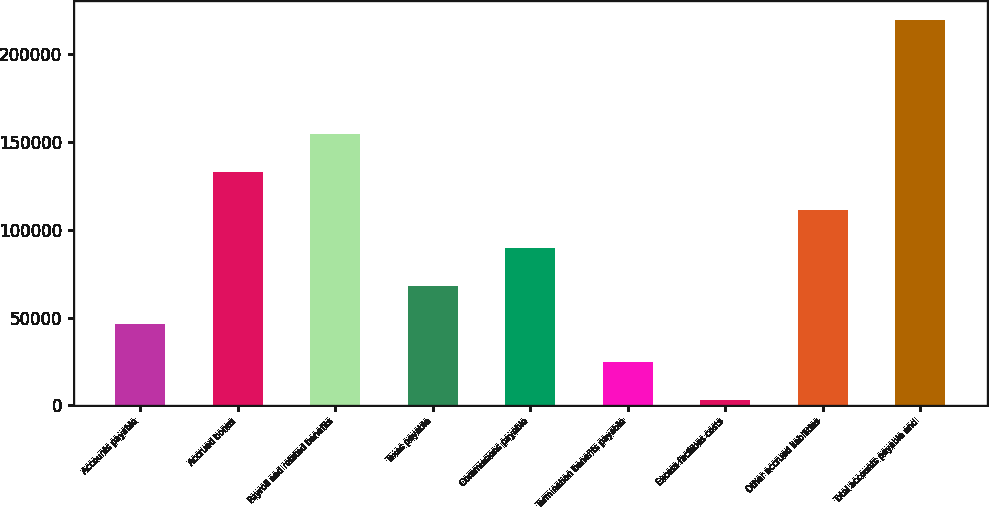<chart> <loc_0><loc_0><loc_500><loc_500><bar_chart><fcel>Accounts payable<fcel>Accrued bonus<fcel>Payroll and related benefits<fcel>Taxes payable<fcel>Commissions payable<fcel>Termination benefits payable<fcel>Excess facilities costs<fcel>Other accrued liabilities<fcel>Total accounts payable and<nl><fcel>46525<fcel>132953<fcel>154560<fcel>68132<fcel>89739<fcel>24918<fcel>3311<fcel>111346<fcel>219381<nl></chart> 